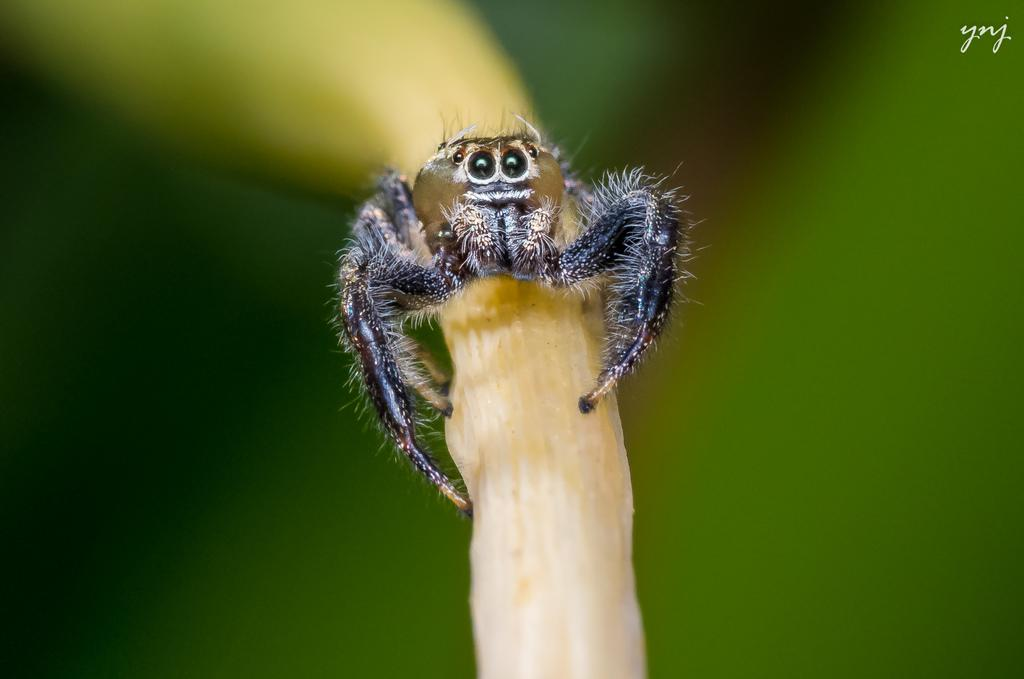What is present in the image? There is an insect in the image. Where is the insect located? The insect is on an object. Can you describe the background of the image? The background of the image is blurry. What nation is represented by the clock in the image? There is no clock present in the image, and therefore no nation can be associated with it. 